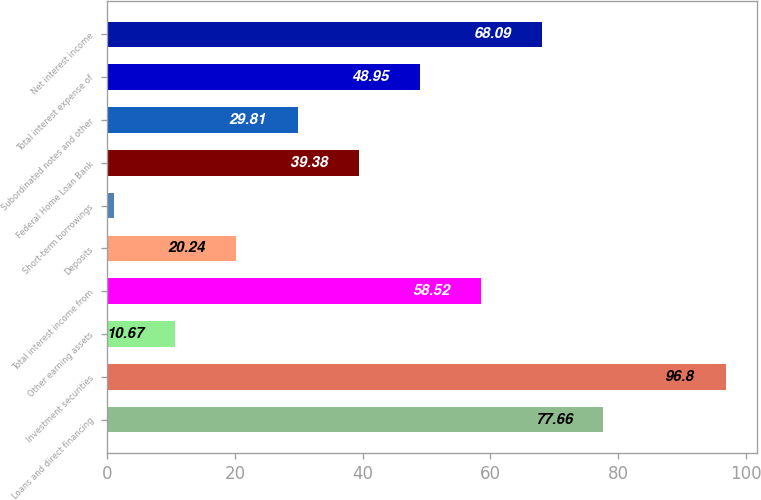Convert chart to OTSL. <chart><loc_0><loc_0><loc_500><loc_500><bar_chart><fcel>Loans and direct financing<fcel>Investment securities<fcel>Other earning assets<fcel>Total interest income from<fcel>Deposits<fcel>Short-term borrowings<fcel>Federal Home Loan Bank<fcel>Subordinated notes and other<fcel>Total interest expense of<fcel>Net interest income<nl><fcel>77.66<fcel>96.8<fcel>10.67<fcel>58.52<fcel>20.24<fcel>1.1<fcel>39.38<fcel>29.81<fcel>48.95<fcel>68.09<nl></chart> 